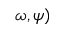Convert formula to latex. <formula><loc_0><loc_0><loc_500><loc_500>\omega , \psi )</formula> 